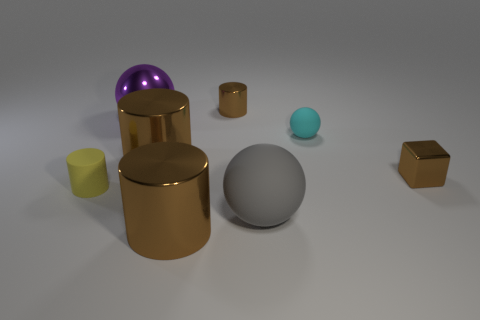What can you infer about the texture of the spherical objects? The textures appear smooth, especially on the spheres, which have a polished finish that reflects the environment with a high degree of clarity and shine. Do you think these objects could serve a practical purpose in real life? While they could resemble aesthetic decorations or elements of a larger artistic installation, their simplistic shapes also allow for a variety of practical uses, such as containers, knobs, or structural elements, depending on the material and scale. 